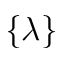Convert formula to latex. <formula><loc_0><loc_0><loc_500><loc_500>\{ \lambda \}</formula> 